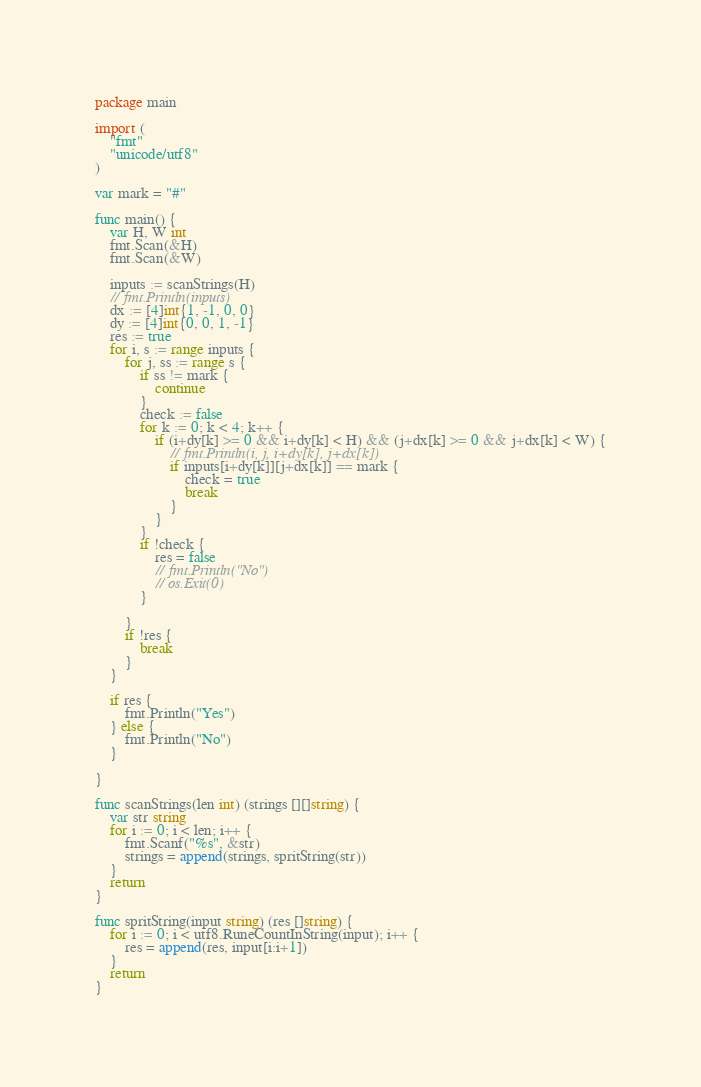Convert code to text. <code><loc_0><loc_0><loc_500><loc_500><_Go_>package main

import (
	"fmt"
	"unicode/utf8"
)

var mark = "#"

func main() {
	var H, W int
	fmt.Scan(&H)
	fmt.Scan(&W)

	inputs := scanStrings(H)
	// fmt.Println(inputs)
	dx := [4]int{1, -1, 0, 0}
	dy := [4]int{0, 0, 1, -1}
	res := true
	for i, s := range inputs {
		for j, ss := range s {
			if ss != mark {
				continue
			}
			check := false
			for k := 0; k < 4; k++ {
				if (i+dy[k] >= 0 && i+dy[k] < H) && (j+dx[k] >= 0 && j+dx[k] < W) {
					// fmt.Println(i, j, i+dy[k], j+dx[k])
					if inputs[i+dy[k]][j+dx[k]] == mark {
						check = true
						break
					}
				}
			}
			if !check {
				res = false
				// fmt.Println("No")
				// os.Exit(0)
			}

		}
		if !res {
			break
		}
	}

	if res {
		fmt.Println("Yes")
	} else {
		fmt.Println("No")
	}

}

func scanStrings(len int) (strings [][]string) {
	var str string
	for i := 0; i < len; i++ {
		fmt.Scanf("%s", &str)
		strings = append(strings, spritString(str))
	}
	return
}

func spritString(input string) (res []string) {
	for i := 0; i < utf8.RuneCountInString(input); i++ {
		res = append(res, input[i:i+1])
	}
	return
}
</code> 